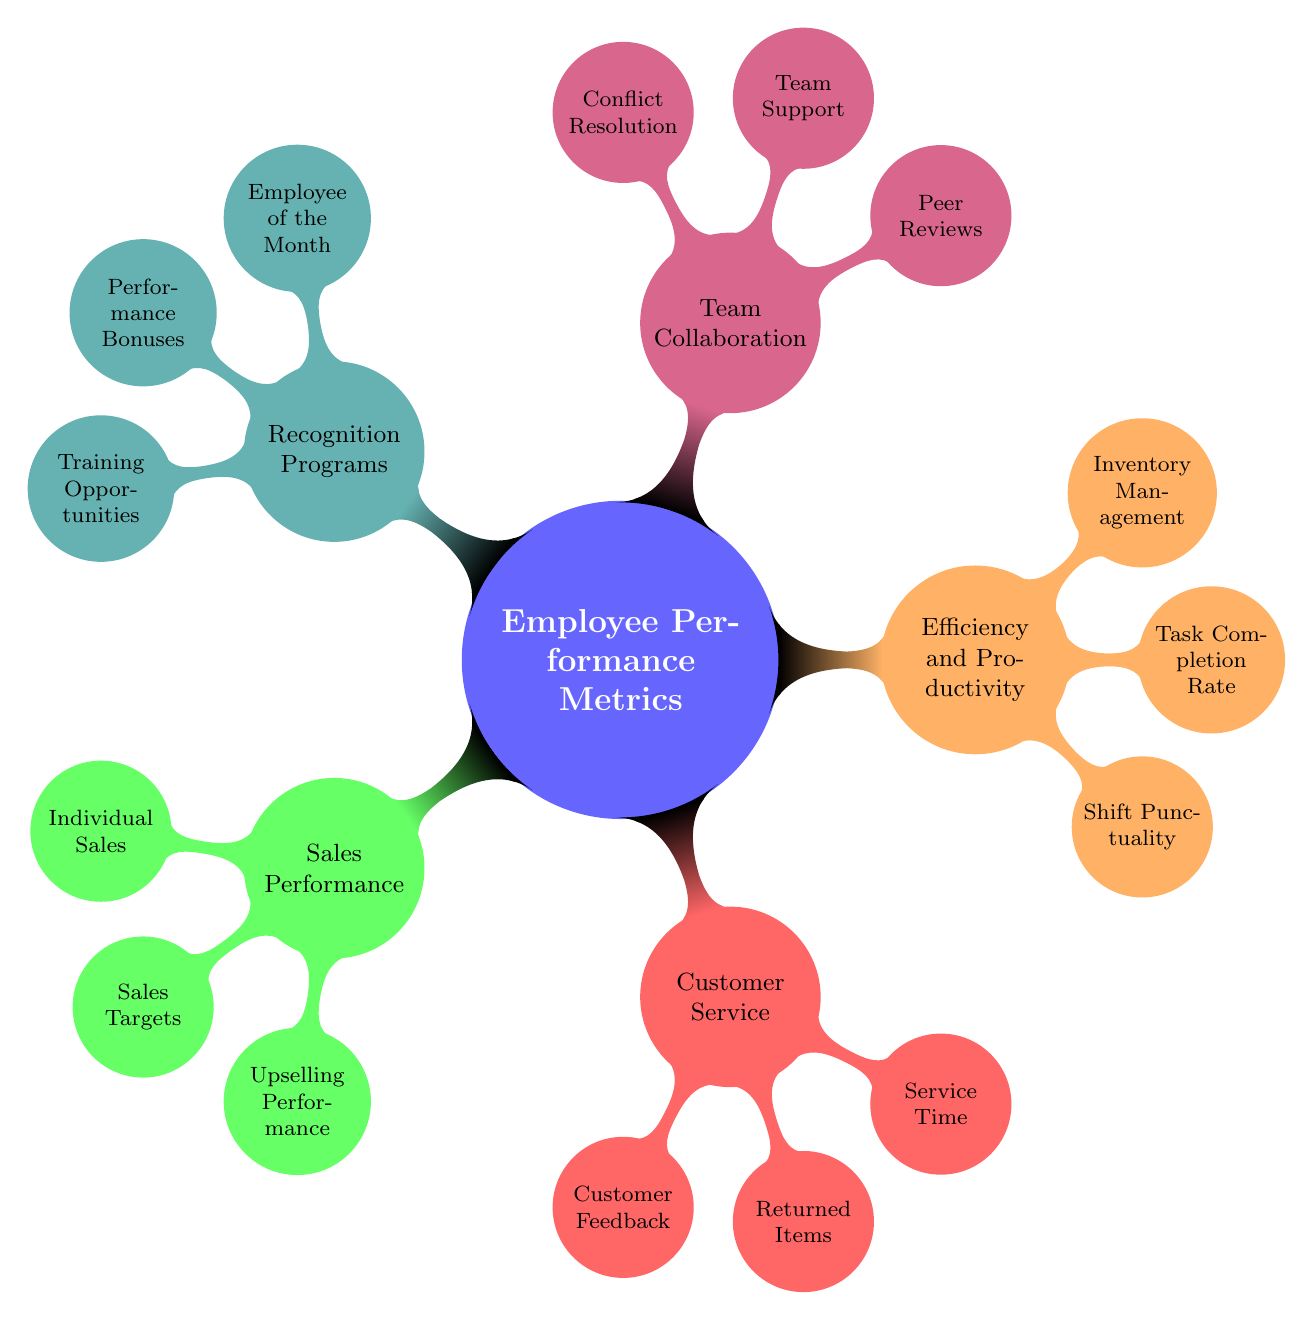What are the main categories of employee performance metrics? The diagram displays five main categories which include Sales Performance, Customer Service, Efficiency and Productivity, Team Collaboration, and Recognition Programs.
Answer: Sales Performance, Customer Service, Efficiency and Productivity, Team Collaboration, Recognition Programs How many nodes are connected to "Team Collaboration"? The "Team Collaboration" category has three nodes connected directly to it, which are Peer Reviews, Team Support, and Conflict Resolution.
Answer: 3 What specific metric measures the frequency of assisting team members? The specific metric that measures the frequency of assisting team members is "Team Support," as highlighted in the "Team Collaboration" section of the diagram.
Answer: Team Support Which metric is designed to assess the timely start and end of shifts? The metric designed to assess the timely start and end of shifts is "Shift Punctuality," located under the Efficiency and Productivity category.
Answer: Shift Punctuality How many total metrics are included under "Recognition Programs"? The "Recognition Programs" category includes three metrics: Employee of the Month, Performance Bonuses, and Training Opportunities. Therefore, the total count is three.
Answer: 3 What metric specifically tracks customer satisfaction? The metric that specifically tracks customer satisfaction is "Customer Feedback," which is part of the Customer Service category in the diagram.
Answer: Customer Feedback Which category includes tracking of returned items handled by each employee? The category that includes tracking returned items handled by each employee is "Customer Service," specifically the node named "Returned Items."
Answer: Customer Service What is the connection between "Performance Bonuses" and employee achievements? "Performance Bonuses," under the Recognition Programs category, are provided as monetary rewards for exceptional performance, directly linking recognition with employee achievements.
Answer: Performance Bonuses 